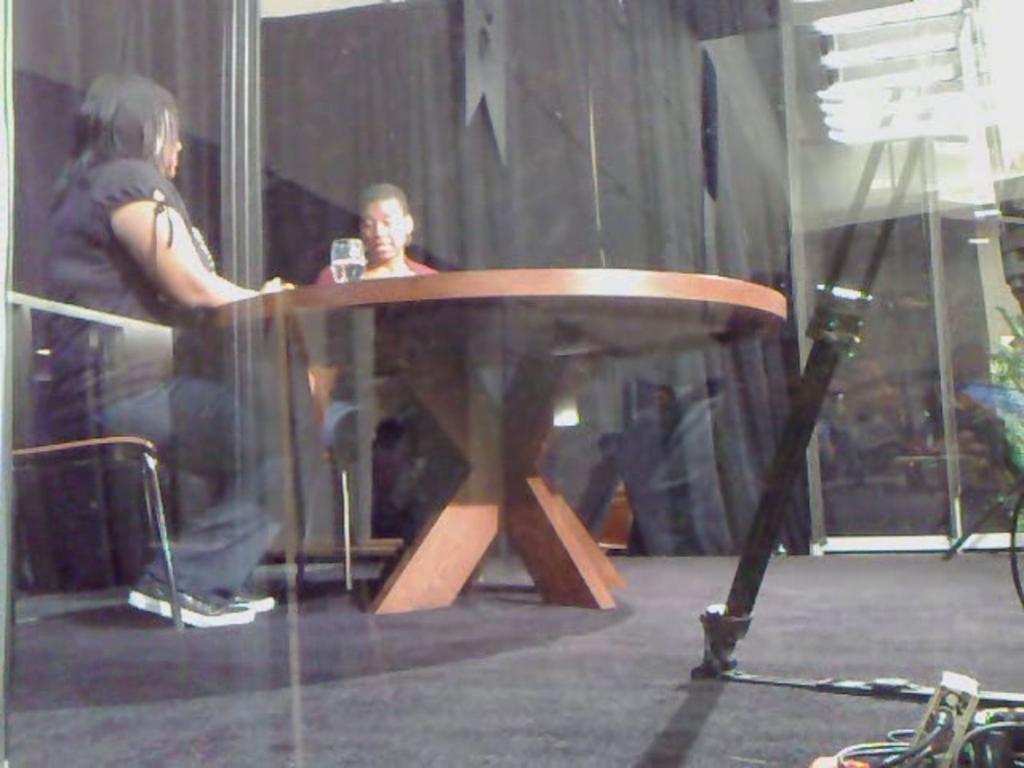How would you summarize this image in a sentence or two? In this image we can see two people sitting on the chairs beside a table containing a glass on it. We can also see a stand and some wires on the floor. On the backside we can see a building. 